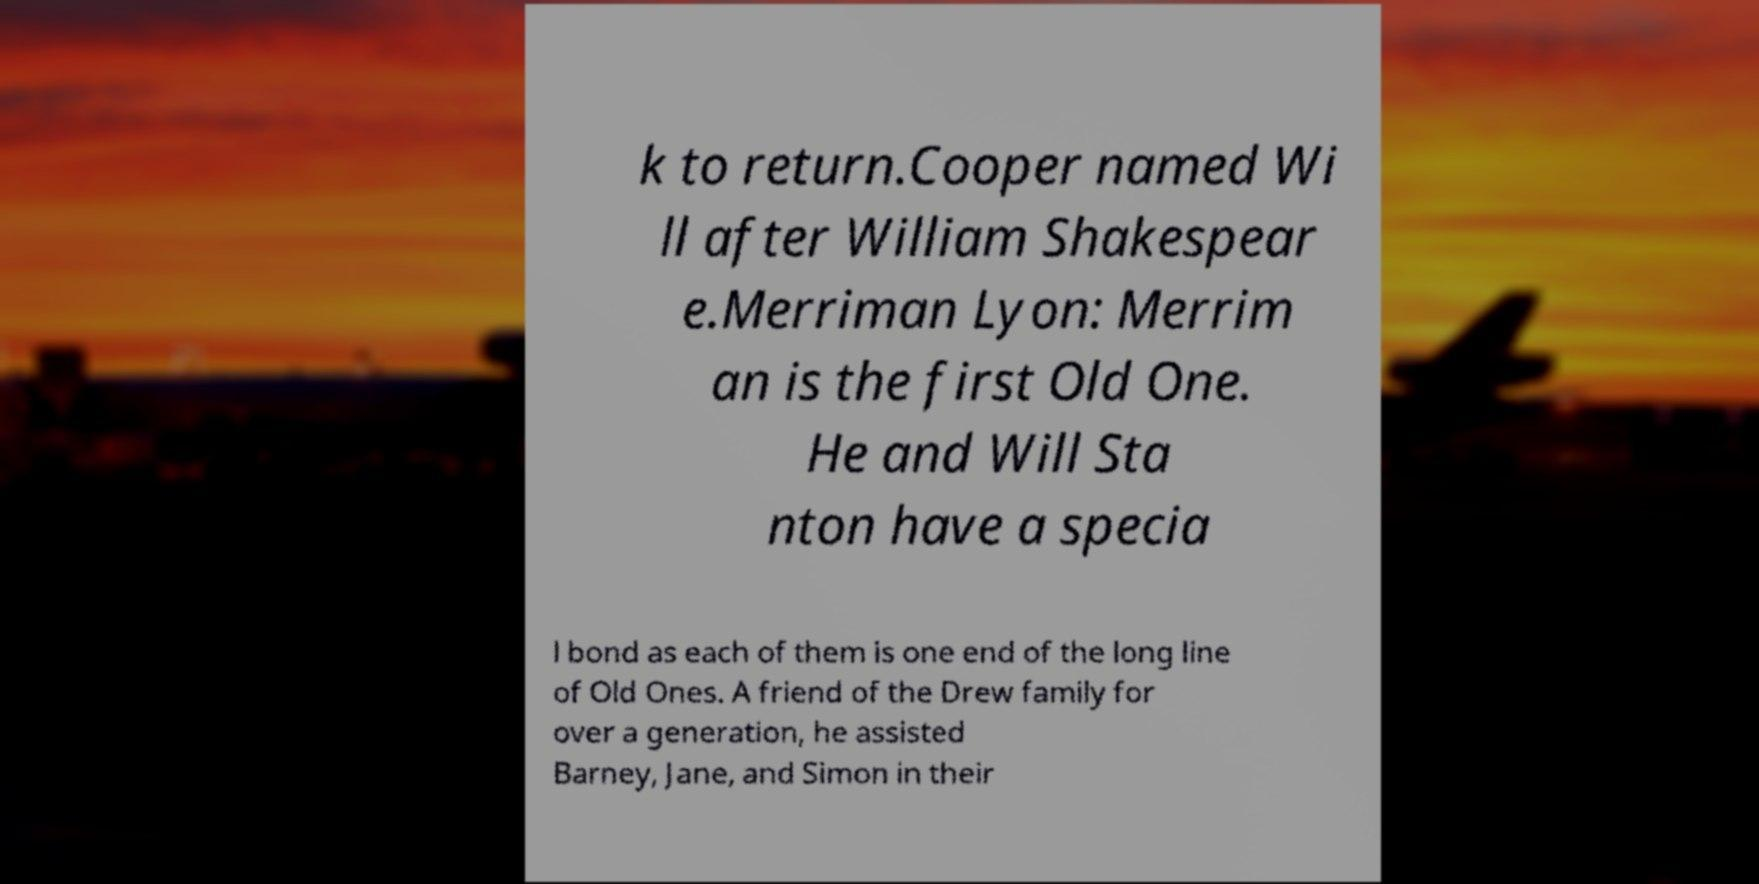For documentation purposes, I need the text within this image transcribed. Could you provide that? k to return.Cooper named Wi ll after William Shakespear e.Merriman Lyon: Merrim an is the first Old One. He and Will Sta nton have a specia l bond as each of them is one end of the long line of Old Ones. A friend of the Drew family for over a generation, he assisted Barney, Jane, and Simon in their 